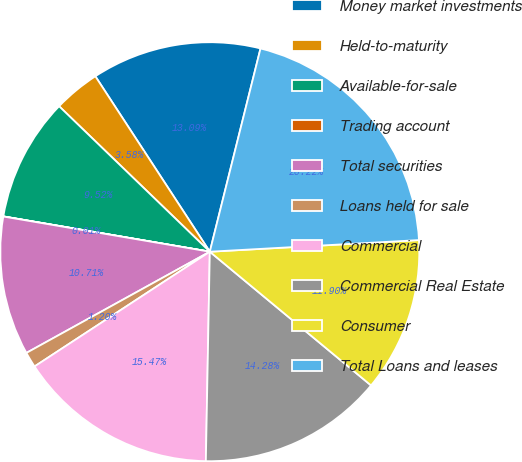Convert chart. <chart><loc_0><loc_0><loc_500><loc_500><pie_chart><fcel>Money market investments<fcel>Held-to-maturity<fcel>Available-for-sale<fcel>Trading account<fcel>Total securities<fcel>Loans held for sale<fcel>Commercial<fcel>Commercial Real Estate<fcel>Consumer<fcel>Total Loans and leases<nl><fcel>13.09%<fcel>3.58%<fcel>9.52%<fcel>0.01%<fcel>10.71%<fcel>1.2%<fcel>15.47%<fcel>14.28%<fcel>11.9%<fcel>20.22%<nl></chart> 